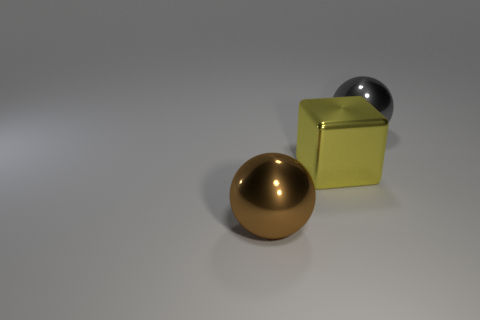Subtract 2 balls. How many balls are left? 0 Subtract all blocks. How many objects are left? 2 Add 3 brown metal things. How many objects exist? 6 Subtract all big gray spheres. Subtract all yellow metallic things. How many objects are left? 1 Add 1 brown shiny things. How many brown shiny things are left? 2 Add 2 big yellow blocks. How many big yellow blocks exist? 3 Subtract 1 gray balls. How many objects are left? 2 Subtract all yellow balls. Subtract all gray blocks. How many balls are left? 2 Subtract all cyan cylinders. How many purple cubes are left? 0 